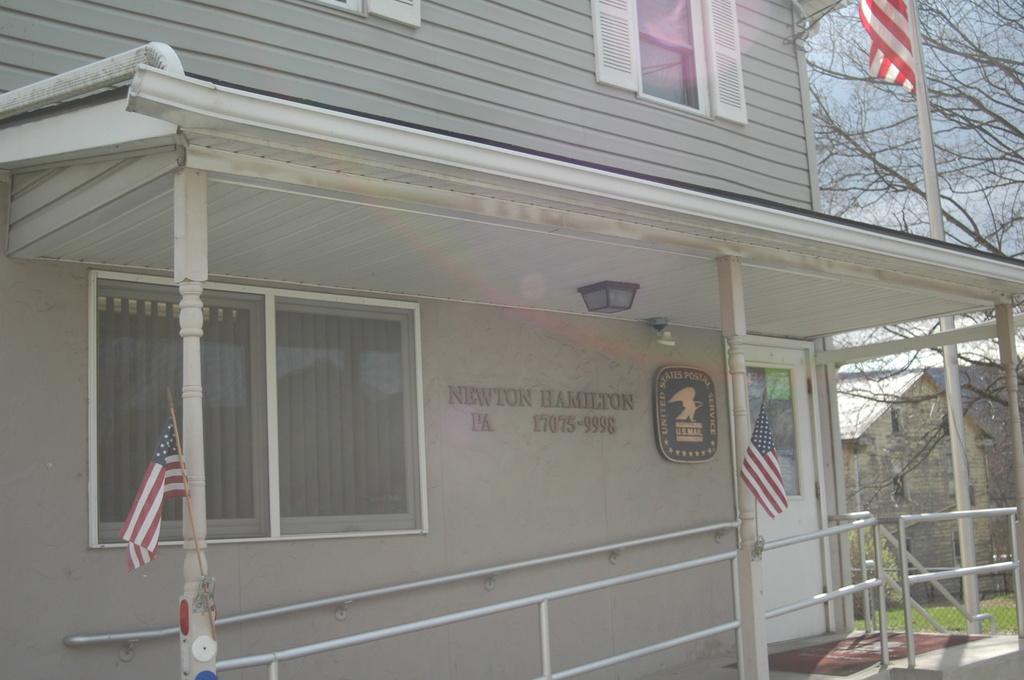Please provide a concise description of this image. In this image I can see a house in the front and on it I can see two flags. I can also see railings, a door, a board, a light, windows and I can see something is written on the wall. On the right side of this image I can see a pole, few trees, one more flag, one more house, grass ground and the sky. 